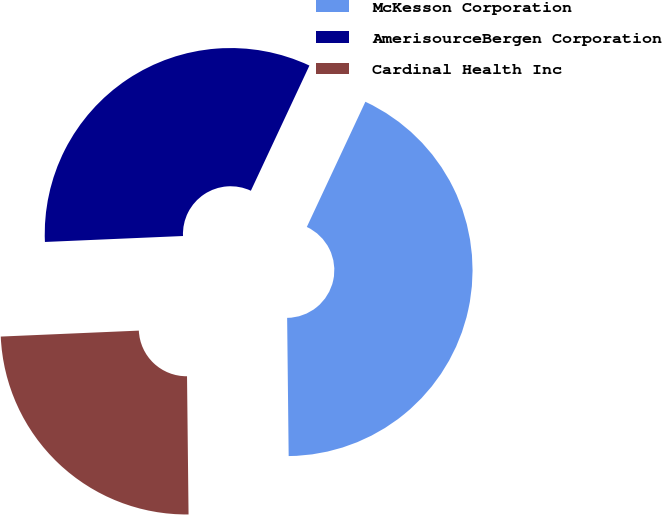Convert chart to OTSL. <chart><loc_0><loc_0><loc_500><loc_500><pie_chart><fcel>McKesson Corporation<fcel>AmerisourceBergen Corporation<fcel>Cardinal Health Inc<nl><fcel>42.86%<fcel>32.65%<fcel>24.49%<nl></chart> 